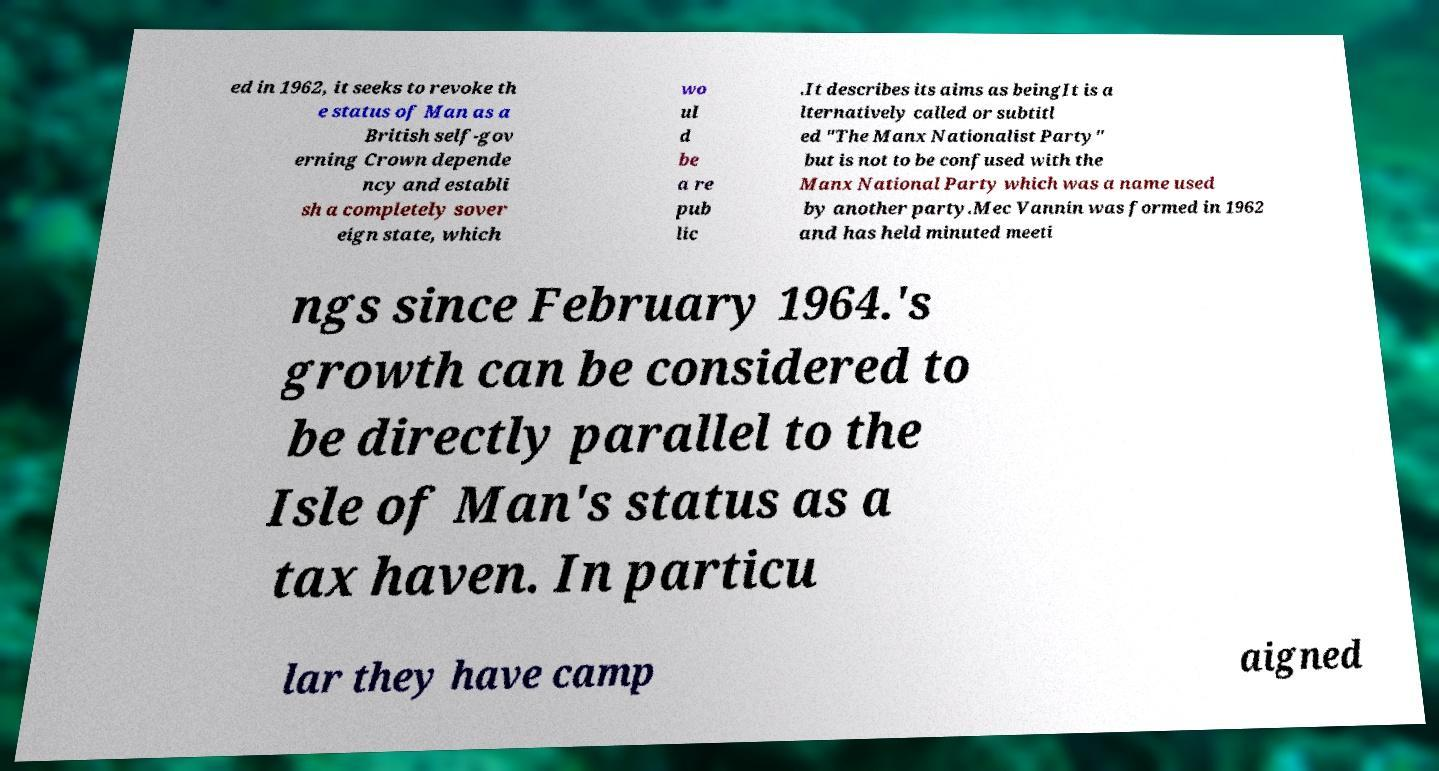Can you accurately transcribe the text from the provided image for me? ed in 1962, it seeks to revoke th e status of Man as a British self-gov erning Crown depende ncy and establi sh a completely sover eign state, which wo ul d be a re pub lic .It describes its aims as beingIt is a lternatively called or subtitl ed "The Manx Nationalist Party" but is not to be confused with the Manx National Party which was a name used by another party.Mec Vannin was formed in 1962 and has held minuted meeti ngs since February 1964.'s growth can be considered to be directly parallel to the Isle of Man's status as a tax haven. In particu lar they have camp aigned 